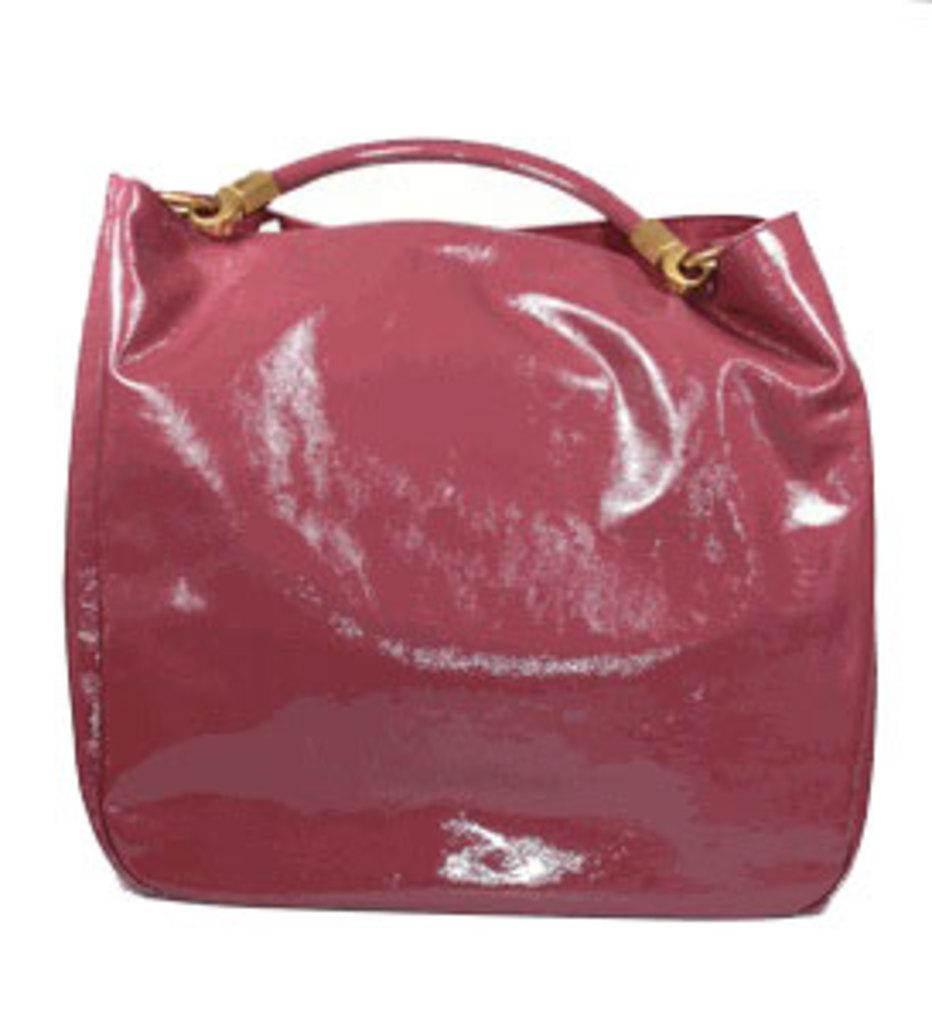What is the color of the bag that is visible in the image? There is a red color bag in the image. What type of material is the steel item made of? The steel item is made of steel. What action is being performed with the steel item in the image? The steel item is handed to the red color bag. How many ladybugs can be seen crawling on the red color bag in the image? There are no ladybugs present on the red color bag in the image. What type of clam is being used as a paperweight on the steel item in the image? There is no clam present in the image, and therefore no such item is being used as a paperweight. 